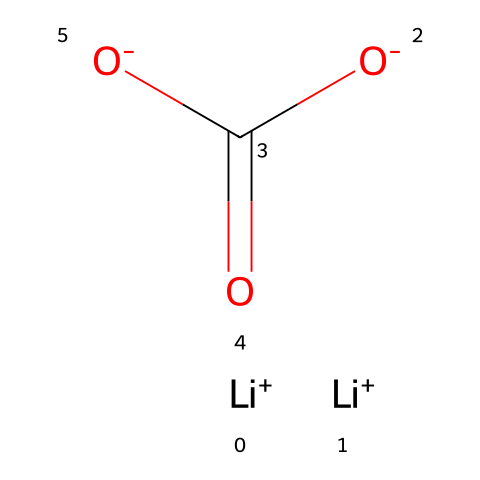What is the central atom in lithium carbonate? The central atom in lithium carbonate can be identified by looking for the atom that is bonded to other atoms and is involved in forming the carbonate ion. In this case, the carbon atom is centrally located and is bonded to three oxygen atoms.
Answer: carbon How many lithium ions are present in lithium carbonate? The structure indicates the presence of two lithium ions, which are represented as [Li+] units in the SMILES.
Answer: two What type of ion is involved in the carbonate part of lithium carbonate? The carbonate portion has a structure that includes a carbon atom double-bonded to one oxygen and single-bonded to two other negatively charged oxygens, which indicates that it forms a polyatomic ion specifically known as carbonate.
Answer: carbonate What is the overall charge of lithium carbonate? The overall structure indicates that there are two positive charges from the lithium ions and two negative charges from the carbonate ion, resulting in a net charge of zero for the compound.
Answer: zero Does lithium carbonate contain any coordination bonds? Coordination bonds typically involve a central metal atom bonded to ligands. In lithium carbonate, while there are ionic interactions, there are no metal-ligand coordination bonds present because lithium does not coordinate in the typical sense.
Answer: no Is the carbonate functional group likely to be acidic or basic in this compound? The carbonate group exhibits acidic characteristics due to its ability to donate protons in solution, which is reflected in the structure where it can act similarly to carboxylic acids.
Answer: acidic 